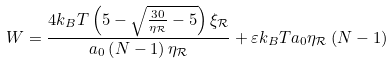Convert formula to latex. <formula><loc_0><loc_0><loc_500><loc_500>W = \frac { 4 k _ { B } T \left ( 5 - \sqrt { \frac { 3 0 } { \eta _ { \mathcal { R } } } - 5 } \right ) \xi _ { \mathcal { R } } } { a _ { 0 } \left ( N - 1 \right ) \eta _ { \mathcal { R } } } + \varepsilon k _ { B } T a _ { 0 } \eta _ { \mathcal { R } } \left ( N - 1 \right )</formula> 